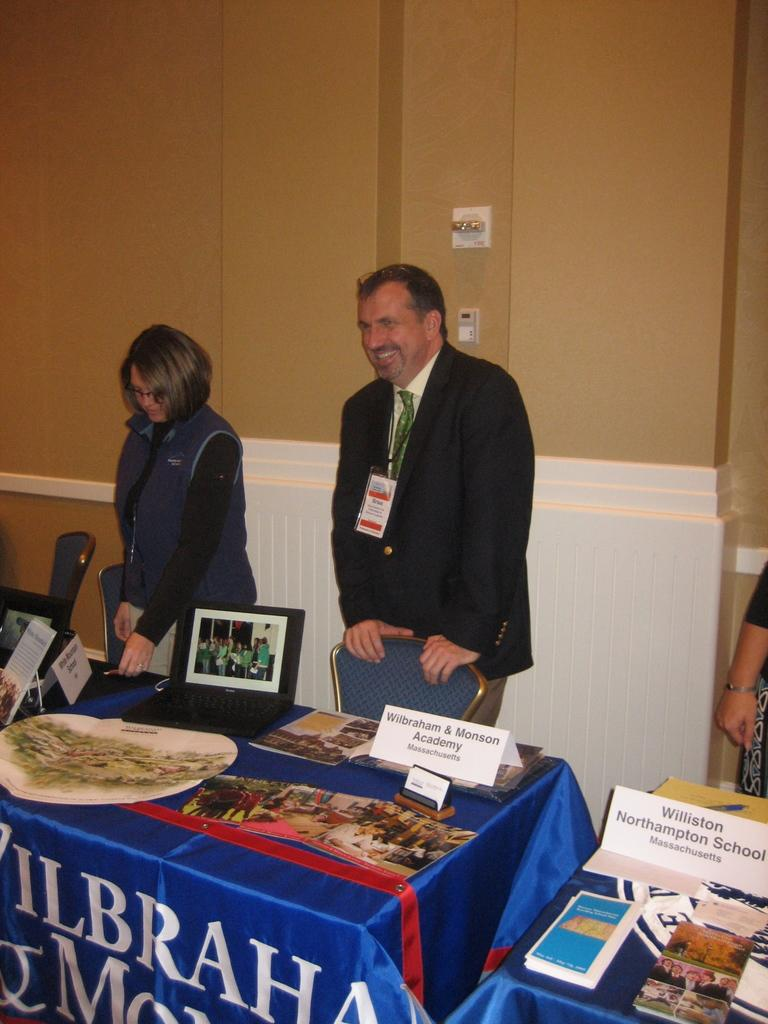<image>
Write a terse but informative summary of the picture. a man in front of a sign that says Wilbraham & Monson Academy 